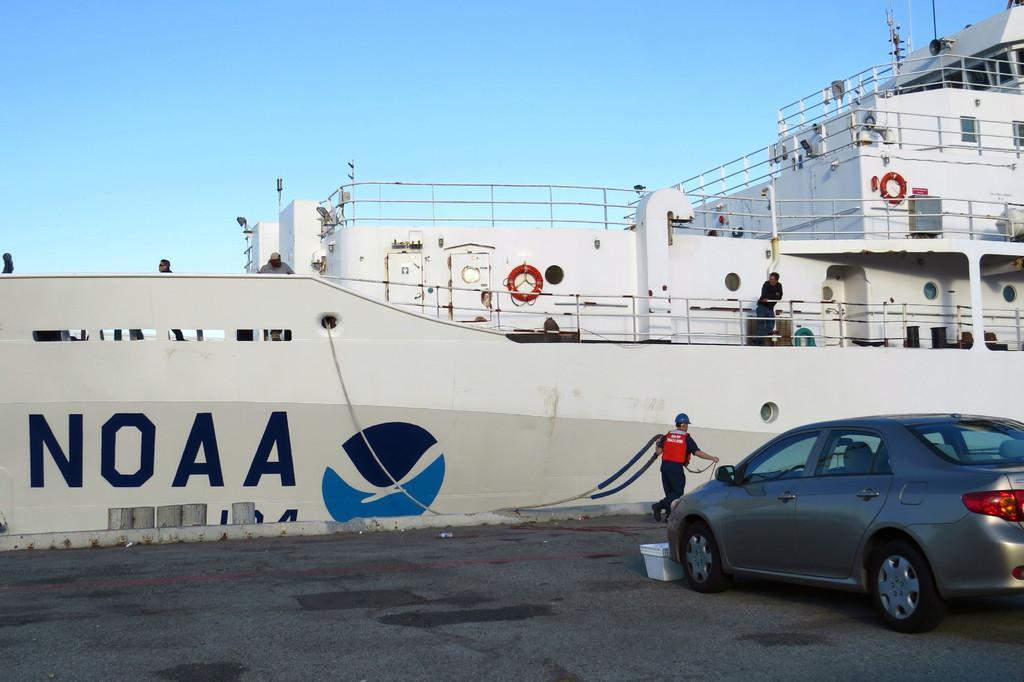Can you describe this image briefly? Here in this picture we can see a ship present over a place and we can see people standing in the ship and on the ground we can see a person wearing an apron and helmet dragging the ropes present over there and in the front we can see a car present on the road and we can see the sky is clear. 